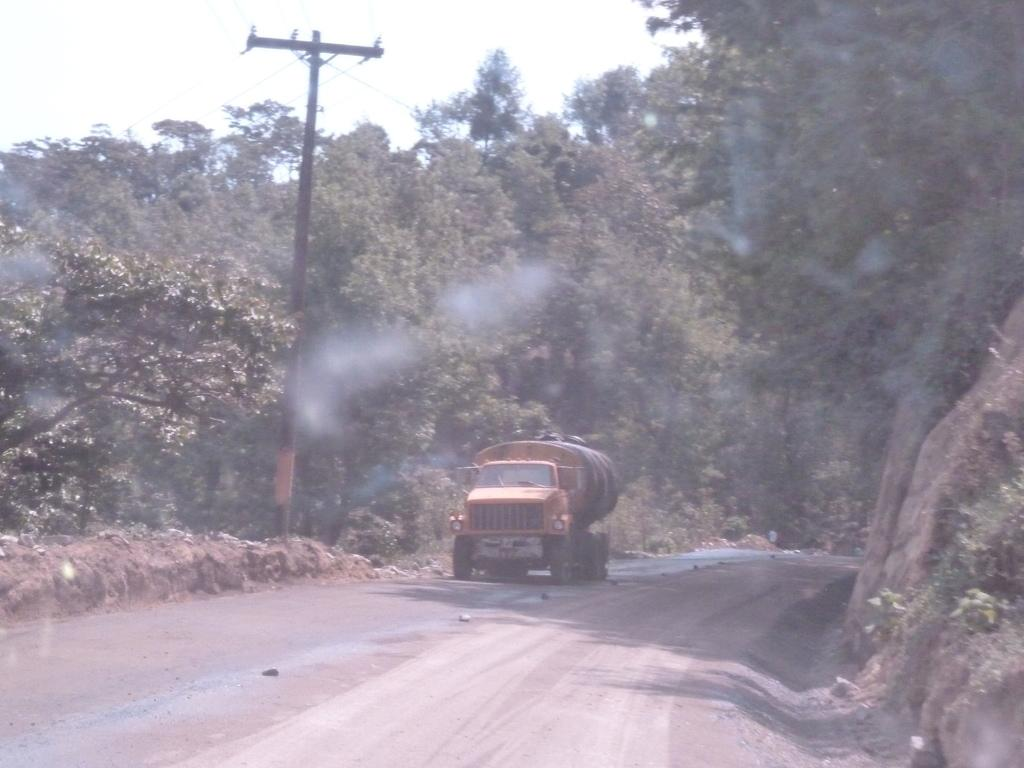What is located in the foreground of the image? There are plants and a road in the foreground of the image, along with soil. What can be seen in the middle of the image? There are trees, a current pole, cables, and a truck in the middle of the image. What is visible at the top of the image? The sky is visible at the top of the image. Can you tell me how many shoes are depicted on the current pole in the image? There are no shoes present on the current pole in the image. What type of patch is visible on the truck in the image? There is no patch visible on the truck in the image. 